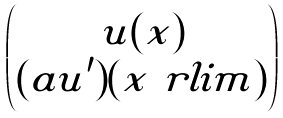Convert formula to latex. <formula><loc_0><loc_0><loc_500><loc_500>\begin{pmatrix} u ( x ) \\ ( a u ^ { \prime } ) ( x \ r l i m ) \end{pmatrix}</formula> 